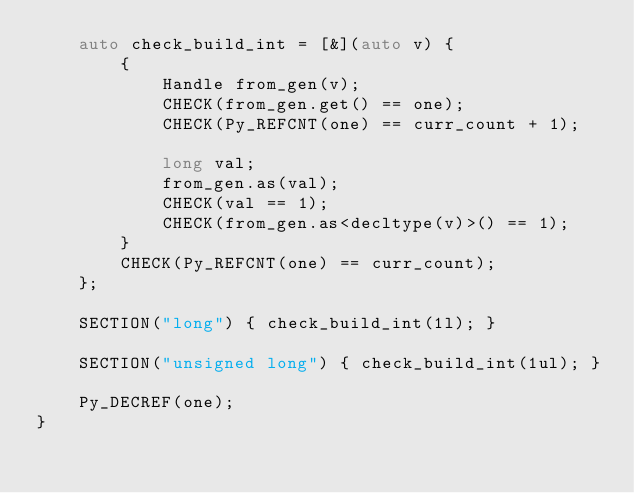<code> <loc_0><loc_0><loc_500><loc_500><_C++_>    auto check_build_int = [&](auto v) {
        {
            Handle from_gen(v);
            CHECK(from_gen.get() == one);
            CHECK(Py_REFCNT(one) == curr_count + 1);

            long val;
            from_gen.as(val);
            CHECK(val == 1);
            CHECK(from_gen.as<decltype(v)>() == 1);
        }
        CHECK(Py_REFCNT(one) == curr_count);
    };

    SECTION("long") { check_build_int(1l); }

    SECTION("unsigned long") { check_build_int(1ul); }

    Py_DECREF(one);
}
</code> 